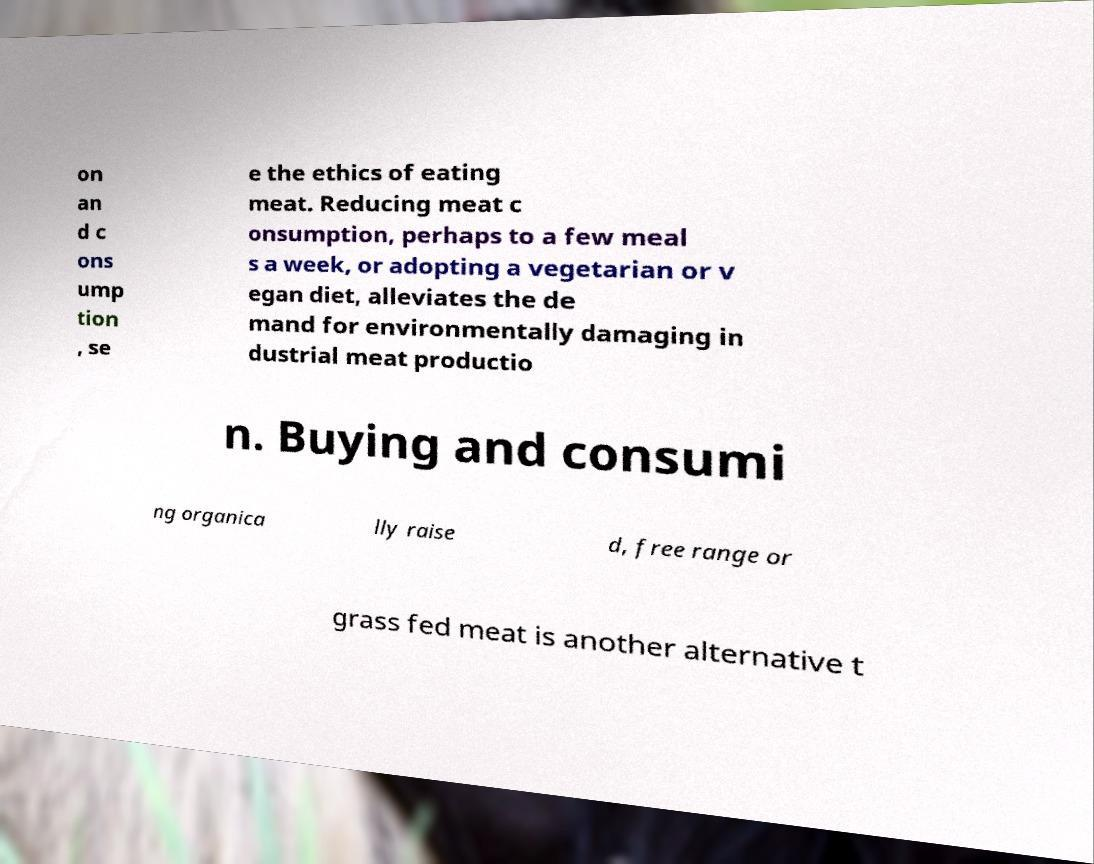What messages or text are displayed in this image? I need them in a readable, typed format. on an d c ons ump tion , se e the ethics of eating meat. Reducing meat c onsumption, perhaps to a few meal s a week, or adopting a vegetarian or v egan diet, alleviates the de mand for environmentally damaging in dustrial meat productio n. Buying and consumi ng organica lly raise d, free range or grass fed meat is another alternative t 